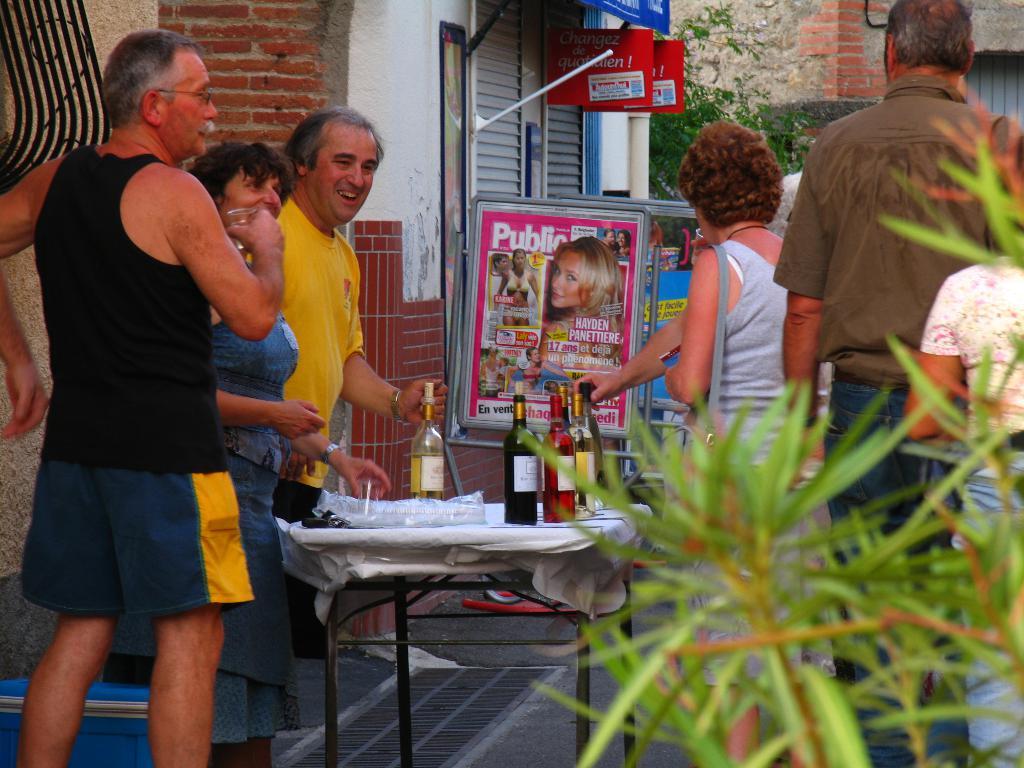What word is on the top left of the board in the background?
Your response must be concise. Public. 